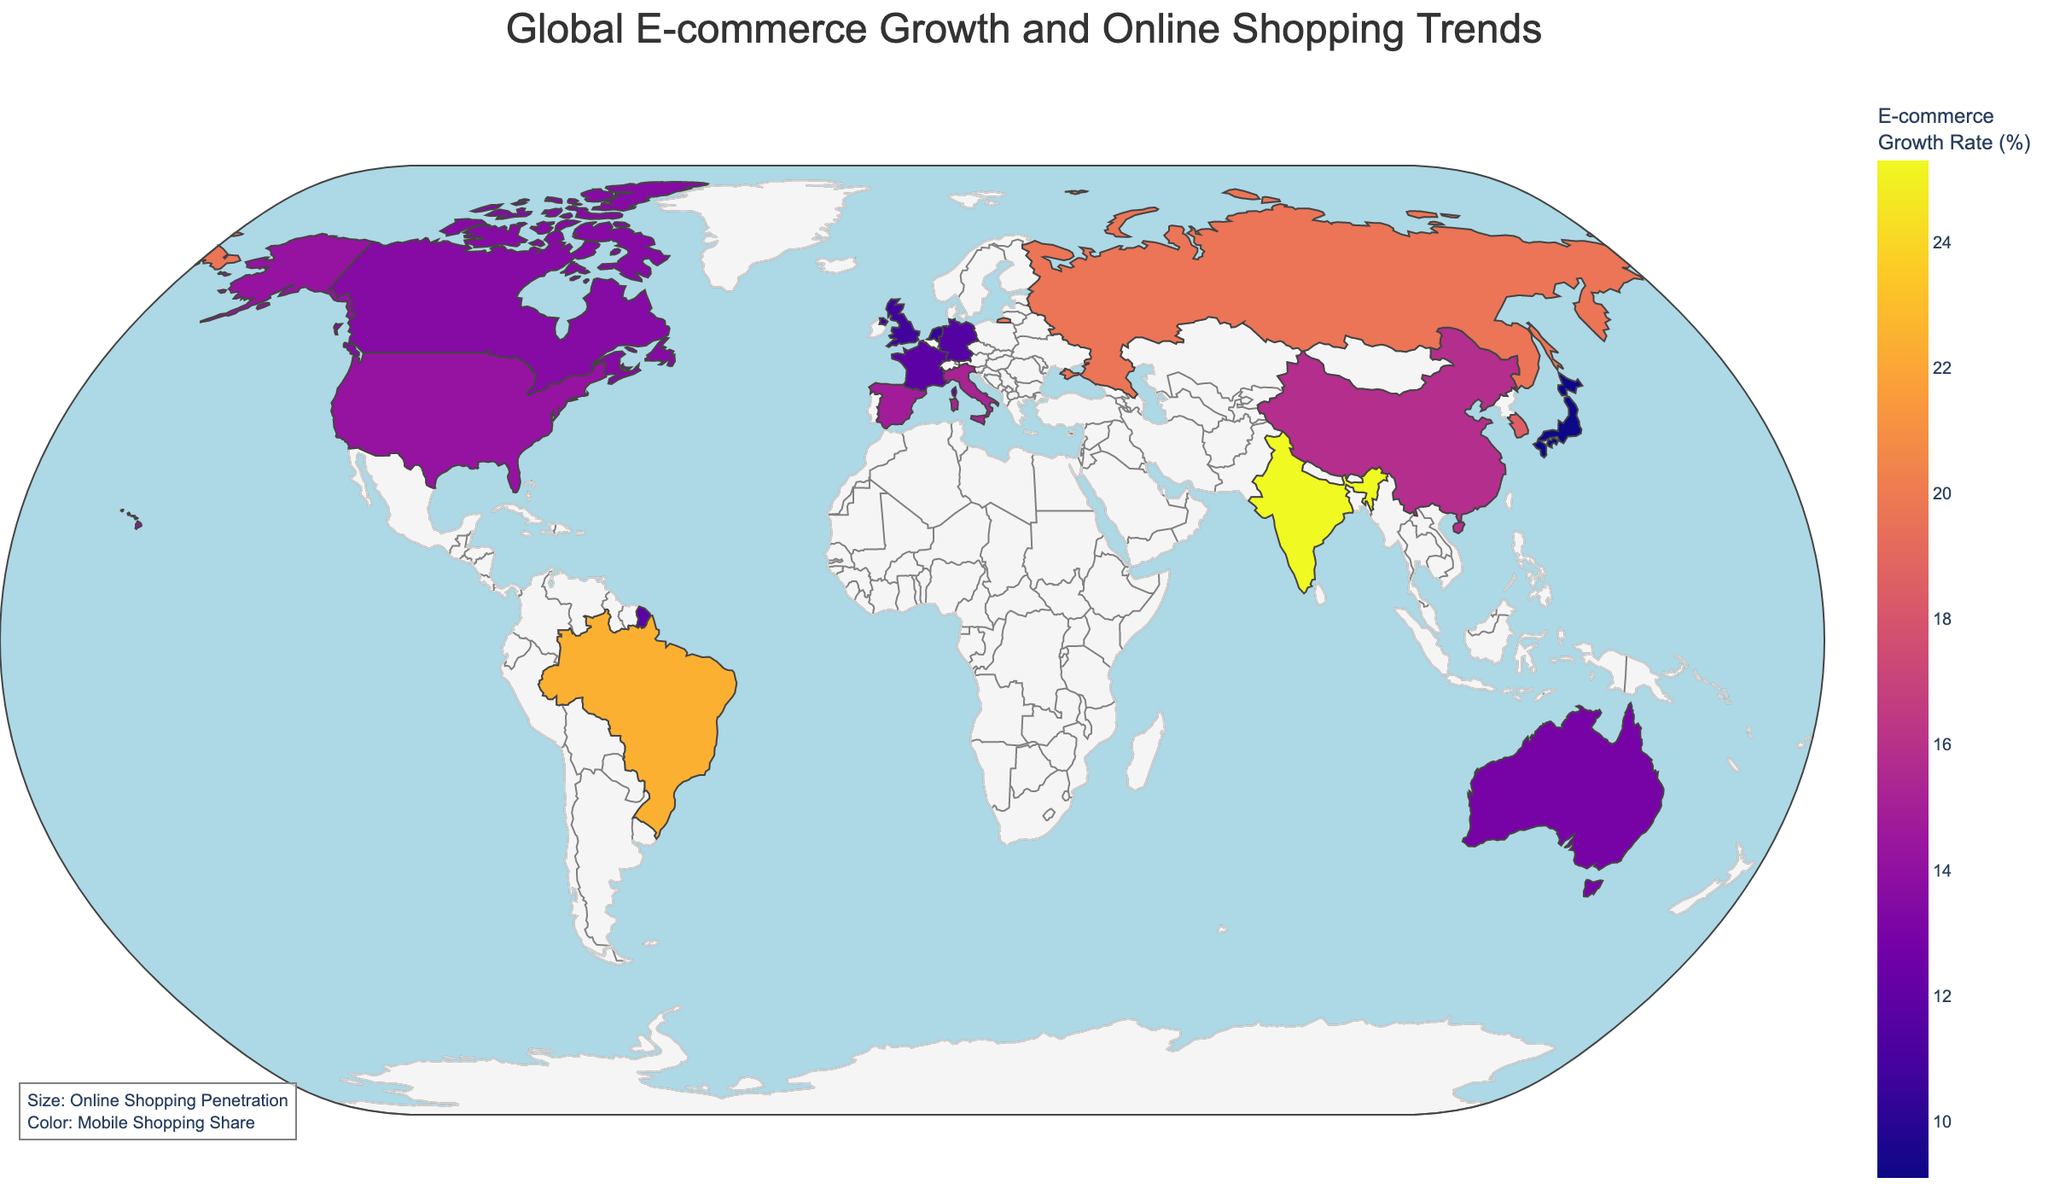What's the title of the figure? The title of the figure is usually displayed prominently at the top of the plot. According to the code provided, the title is set to "Global E-commerce Growth and Online Shopping Trends".
Answer: Global E-commerce Growth and Online Shopping Trends Which country has the highest e-commerce growth rate? To find the country with the highest e-commerce growth rate, refer to the color intensity on the plot as darker colors represent higher rates. Look for the label with the highest value in the hover data. According to the data provided, India has the highest growth rate at 25.3%.
Answer: India How does the online shopping penetration rate of South Korea compare to that of India? To compare the online shopping penetration rates, look at the hover data for both countries. South Korea has an online shopping penetration rate of 90%, while India has a rate of 45%.
Answer: South Korea has a higher rate Which country has a higher percentage of mobile shopping: China or Brazil? Consult the hover data for both China and Brazil to determine their mobile shopping percentages. China has a mobile shopping share of 67.5%, while Brazil's share is 55.7%.
Answer: China Among the European countries listed, which one has the lowest e-commerce growth rate? To find the European country with the lowest e-commerce growth rate, compare the values for the United Kingdom, Germany, France, Italy, Spain, and the Netherlands. According to the data, the Netherlands has the lowest rate at 10.3%.
Answer: Netherlands What is the cross-border e-commerce percentage for Australia, and how does it compare to France? The cross-border e-commerce percentage for Australia can be found in the hover data; it is 29%. France has a cross-border e-commerce percentage of 22%. Therefore, Australia's percentage is higher.
Answer: 29%, higher than France Which country has the highest online shopping penetration rate? To determine the highest online shopping penetration rate, hover over each country or reference the plot characteristics. South Korea has the highest penetration rate at 90%.
Answer: South Korea How does the mobile shopping share of Russia compare to that of Germany? Reference the hover data for both Russia and Germany to determine their mobile shopping shares. Russia's mobile shopping share is 61.4%, while Germany's is 47.2%.
Answer: Russia has a higher share Which two countries have the closest e-commerce growth rates? Examine the plot and hover data to find similar values. The United States with 14.2% and Spain with 14.8% have very close e-commerce growth rates.
Answer: United States and Spain Among the countries listed, which one has the lowest percentage of cross-border e-commerce? To find the country with the lowest percentage of cross-border e-commerce, compare the values in the hover data. Brazil has the lowest percentage at 9%.
Answer: Brazil 